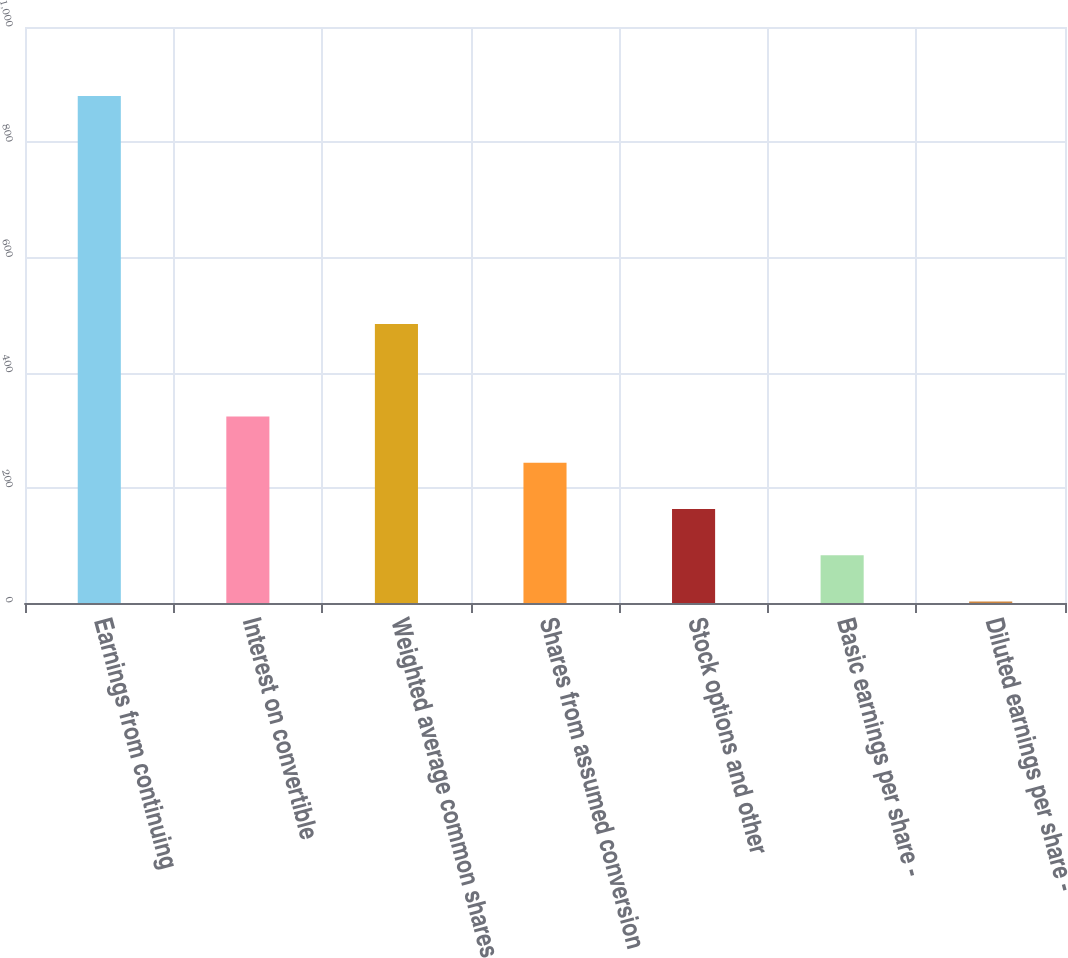Convert chart. <chart><loc_0><loc_0><loc_500><loc_500><bar_chart><fcel>Earnings from continuing<fcel>Interest on convertible<fcel>Weighted average common shares<fcel>Shares from assumed conversion<fcel>Stock options and other<fcel>Basic earnings per share -<fcel>Diluted earnings per share -<nl><fcel>880.36<fcel>323.85<fcel>484.57<fcel>243.49<fcel>163.13<fcel>82.77<fcel>2.41<nl></chart> 